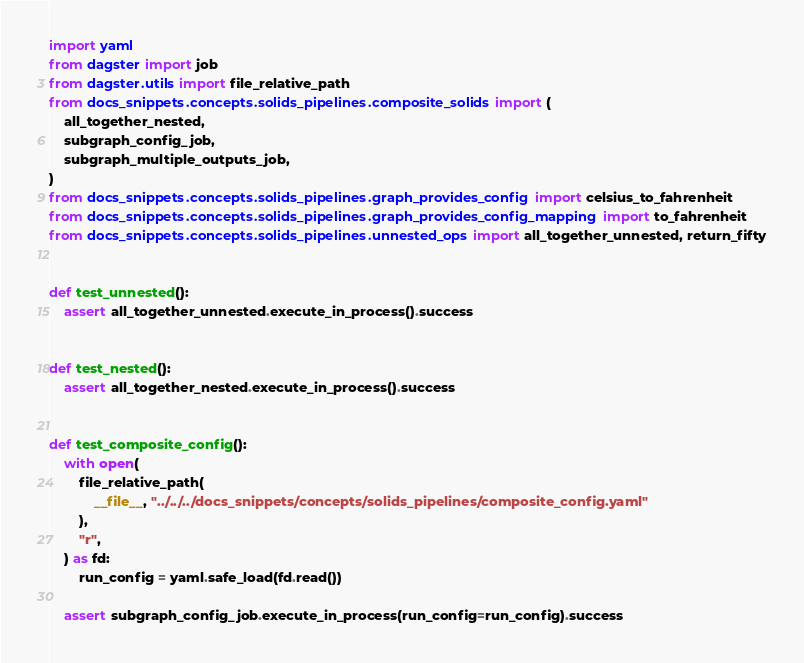Convert code to text. <code><loc_0><loc_0><loc_500><loc_500><_Python_>import yaml
from dagster import job
from dagster.utils import file_relative_path
from docs_snippets.concepts.solids_pipelines.composite_solids import (
    all_together_nested,
    subgraph_config_job,
    subgraph_multiple_outputs_job,
)
from docs_snippets.concepts.solids_pipelines.graph_provides_config import celsius_to_fahrenheit
from docs_snippets.concepts.solids_pipelines.graph_provides_config_mapping import to_fahrenheit
from docs_snippets.concepts.solids_pipelines.unnested_ops import all_together_unnested, return_fifty


def test_unnested():
    assert all_together_unnested.execute_in_process().success


def test_nested():
    assert all_together_nested.execute_in_process().success


def test_composite_config():
    with open(
        file_relative_path(
            __file__, "../../../docs_snippets/concepts/solids_pipelines/composite_config.yaml"
        ),
        "r",
    ) as fd:
        run_config = yaml.safe_load(fd.read())

    assert subgraph_config_job.execute_in_process(run_config=run_config).success

</code> 